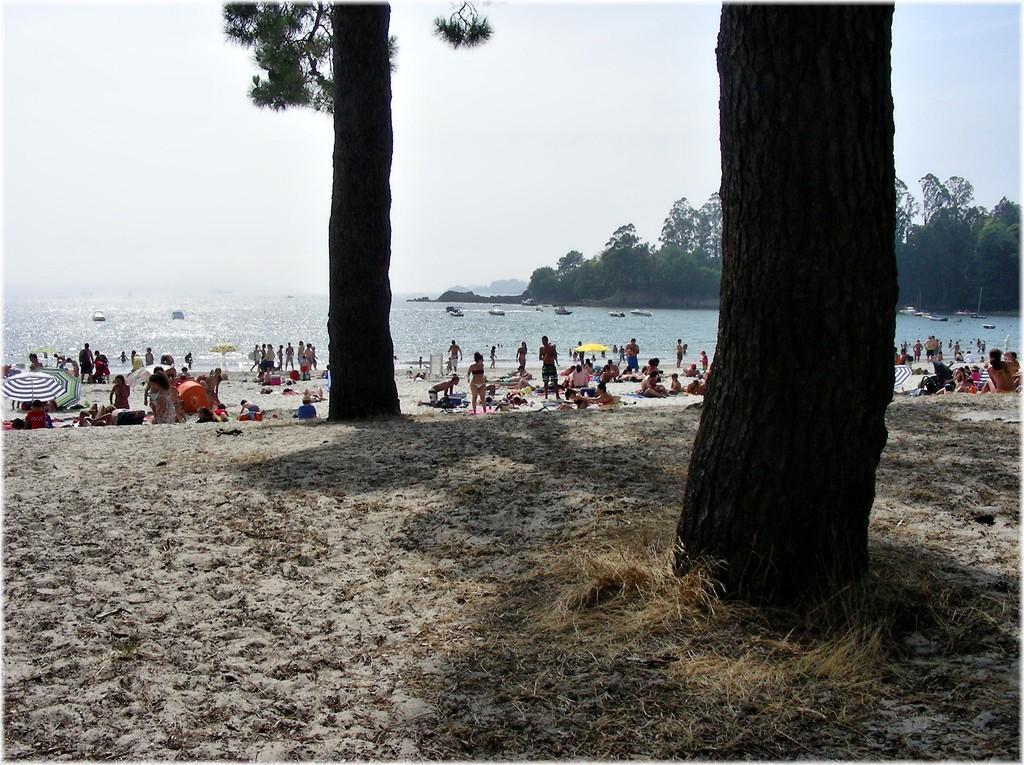Could you give a brief overview of what you see in this image? In this image, we can see people and there are umbrellas, chairs and some other objects. At the top, there is sky and at the bottom, there are boats on the water and we can see sand. 